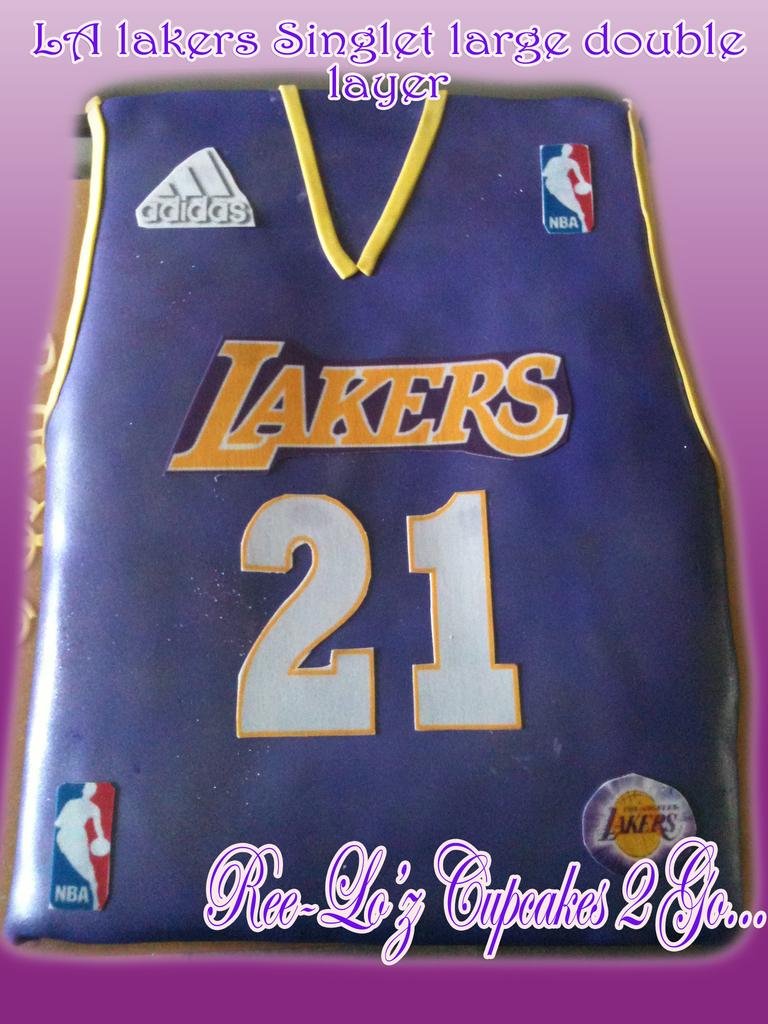What nba team is this cake displaying?
Offer a terse response. Lakers. 